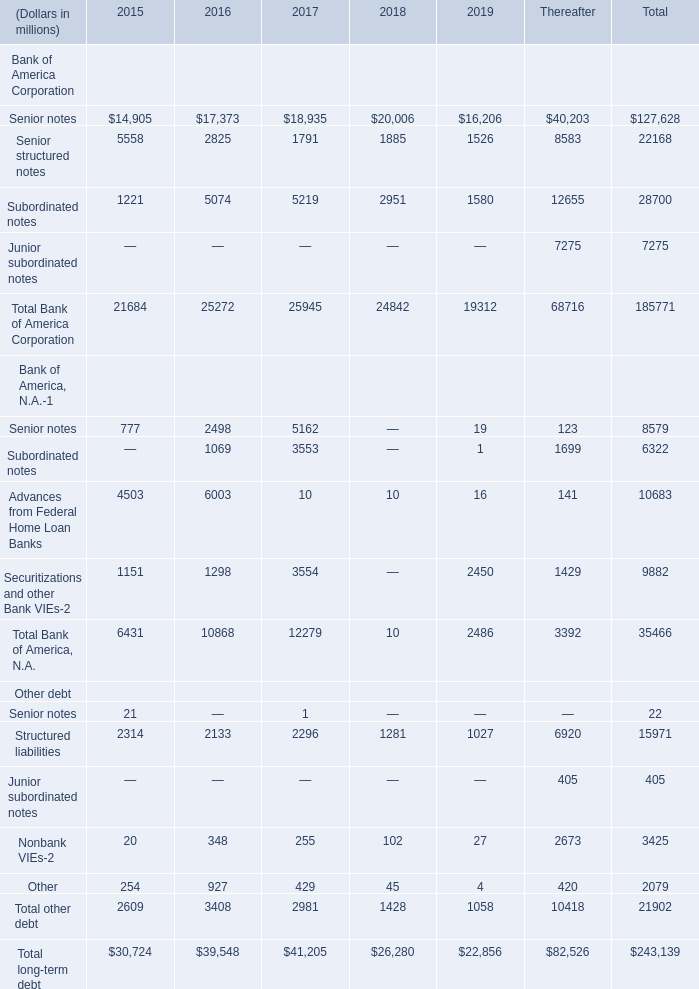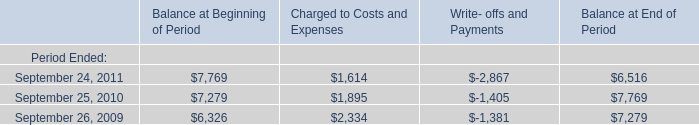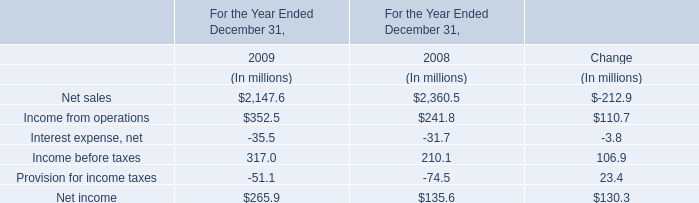What's the growth rate of Total long-term debt in 2019? 
Computations: ((22856 - 26280) / 26280)
Answer: -0.13029. 